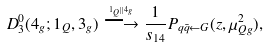Convert formula to latex. <formula><loc_0><loc_0><loc_500><loc_500>D _ { 3 } ^ { 0 } ( 4 _ { g } ; 1 _ { Q } , 3 _ { g } ) \stackrel { ^ { 1 _ { Q } | | 4 _ { g } } } { \longrightarrow } \frac { 1 } { s _ { 1 4 } } P _ { q \bar { q } \leftarrow G } ( z , \mu _ { Q g } ^ { 2 } ) ,</formula> 